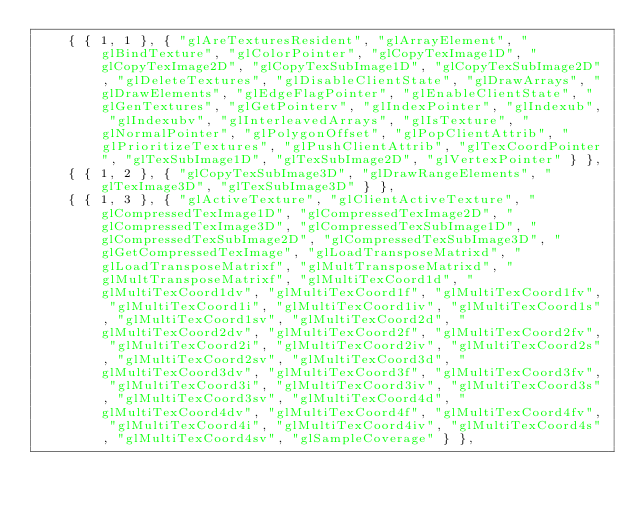<code> <loc_0><loc_0><loc_500><loc_500><_C++_>    { { 1, 1 }, { "glAreTexturesResident", "glArrayElement", "glBindTexture", "glColorPointer", "glCopyTexImage1D", "glCopyTexImage2D", "glCopyTexSubImage1D", "glCopyTexSubImage2D", "glDeleteTextures", "glDisableClientState", "glDrawArrays", "glDrawElements", "glEdgeFlagPointer", "glEnableClientState", "glGenTextures", "glGetPointerv", "glIndexPointer", "glIndexub", "glIndexubv", "glInterleavedArrays", "glIsTexture", "glNormalPointer", "glPolygonOffset", "glPopClientAttrib", "glPrioritizeTextures", "glPushClientAttrib", "glTexCoordPointer", "glTexSubImage1D", "glTexSubImage2D", "glVertexPointer" } },
    { { 1, 2 }, { "glCopyTexSubImage3D", "glDrawRangeElements", "glTexImage3D", "glTexSubImage3D" } },
    { { 1, 3 }, { "glActiveTexture", "glClientActiveTexture", "glCompressedTexImage1D", "glCompressedTexImage2D", "glCompressedTexImage3D", "glCompressedTexSubImage1D", "glCompressedTexSubImage2D", "glCompressedTexSubImage3D", "glGetCompressedTexImage", "glLoadTransposeMatrixd", "glLoadTransposeMatrixf", "glMultTransposeMatrixd", "glMultTransposeMatrixf", "glMultiTexCoord1d", "glMultiTexCoord1dv", "glMultiTexCoord1f", "glMultiTexCoord1fv", "glMultiTexCoord1i", "glMultiTexCoord1iv", "glMultiTexCoord1s", "glMultiTexCoord1sv", "glMultiTexCoord2d", "glMultiTexCoord2dv", "glMultiTexCoord2f", "glMultiTexCoord2fv", "glMultiTexCoord2i", "glMultiTexCoord2iv", "glMultiTexCoord2s", "glMultiTexCoord2sv", "glMultiTexCoord3d", "glMultiTexCoord3dv", "glMultiTexCoord3f", "glMultiTexCoord3fv", "glMultiTexCoord3i", "glMultiTexCoord3iv", "glMultiTexCoord3s", "glMultiTexCoord3sv", "glMultiTexCoord4d", "glMultiTexCoord4dv", "glMultiTexCoord4f", "glMultiTexCoord4fv", "glMultiTexCoord4i", "glMultiTexCoord4iv", "glMultiTexCoord4s", "glMultiTexCoord4sv", "glSampleCoverage" } },</code> 